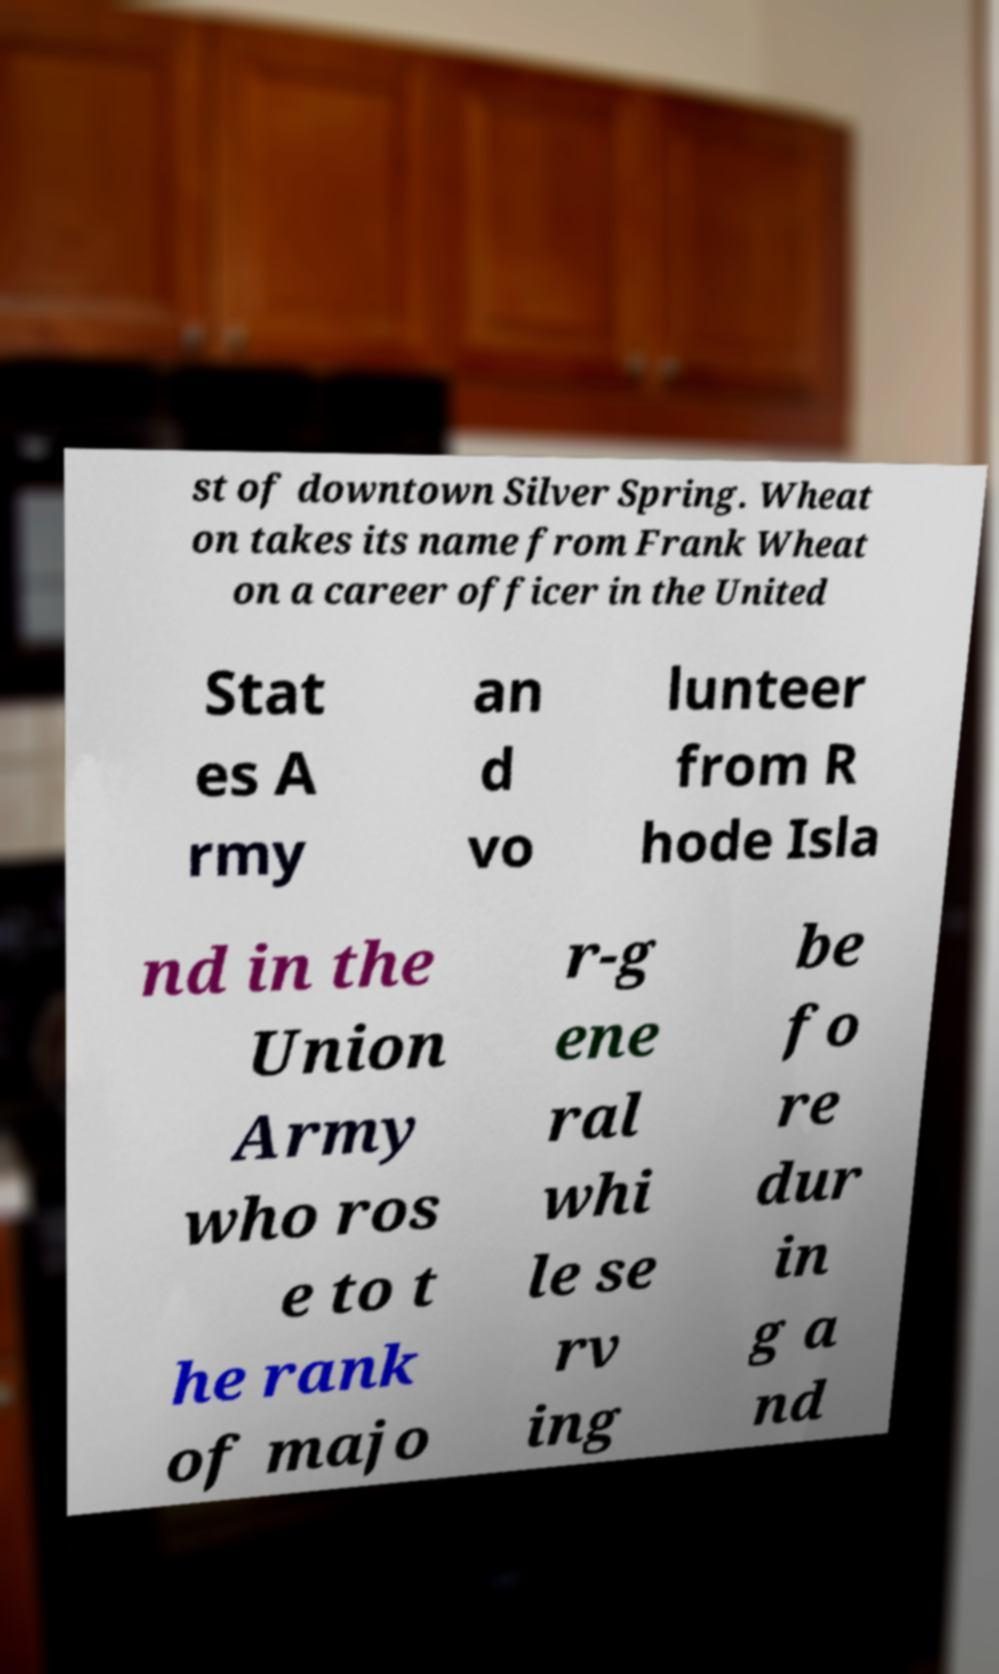Can you read and provide the text displayed in the image?This photo seems to have some interesting text. Can you extract and type it out for me? st of downtown Silver Spring. Wheat on takes its name from Frank Wheat on a career officer in the United Stat es A rmy an d vo lunteer from R hode Isla nd in the Union Army who ros e to t he rank of majo r-g ene ral whi le se rv ing be fo re dur in g a nd 